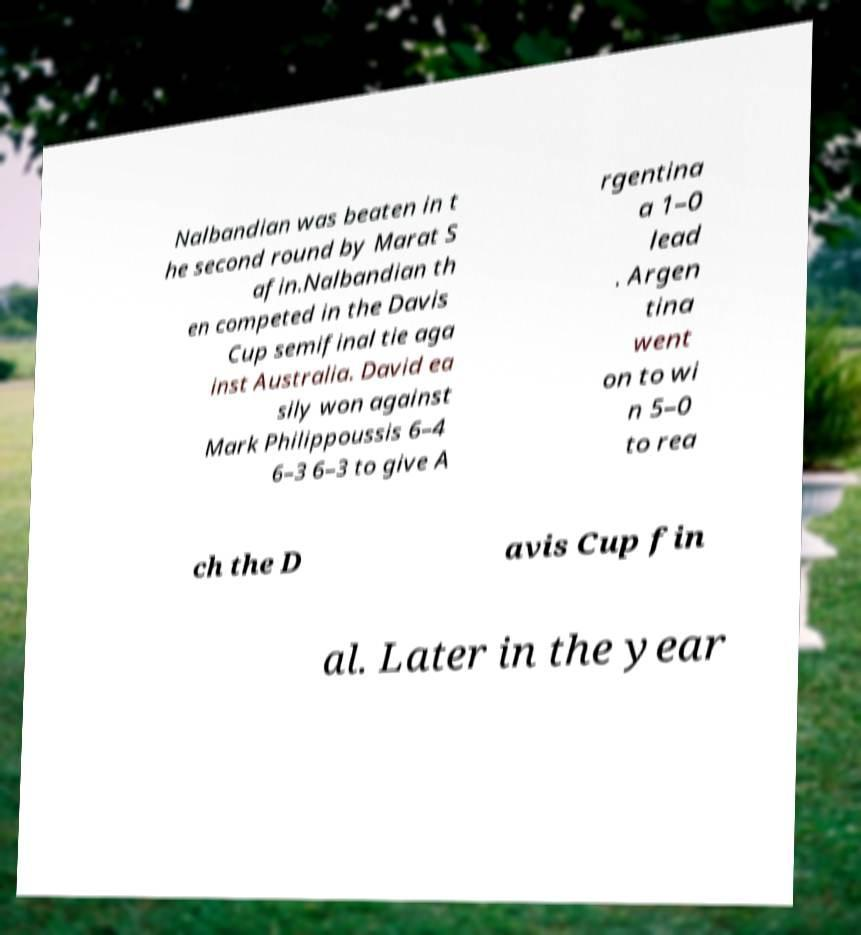Could you assist in decoding the text presented in this image and type it out clearly? Nalbandian was beaten in t he second round by Marat S afin.Nalbandian th en competed in the Davis Cup semifinal tie aga inst Australia. David ea sily won against Mark Philippoussis 6–4 6–3 6–3 to give A rgentina a 1–0 lead . Argen tina went on to wi n 5–0 to rea ch the D avis Cup fin al. Later in the year 